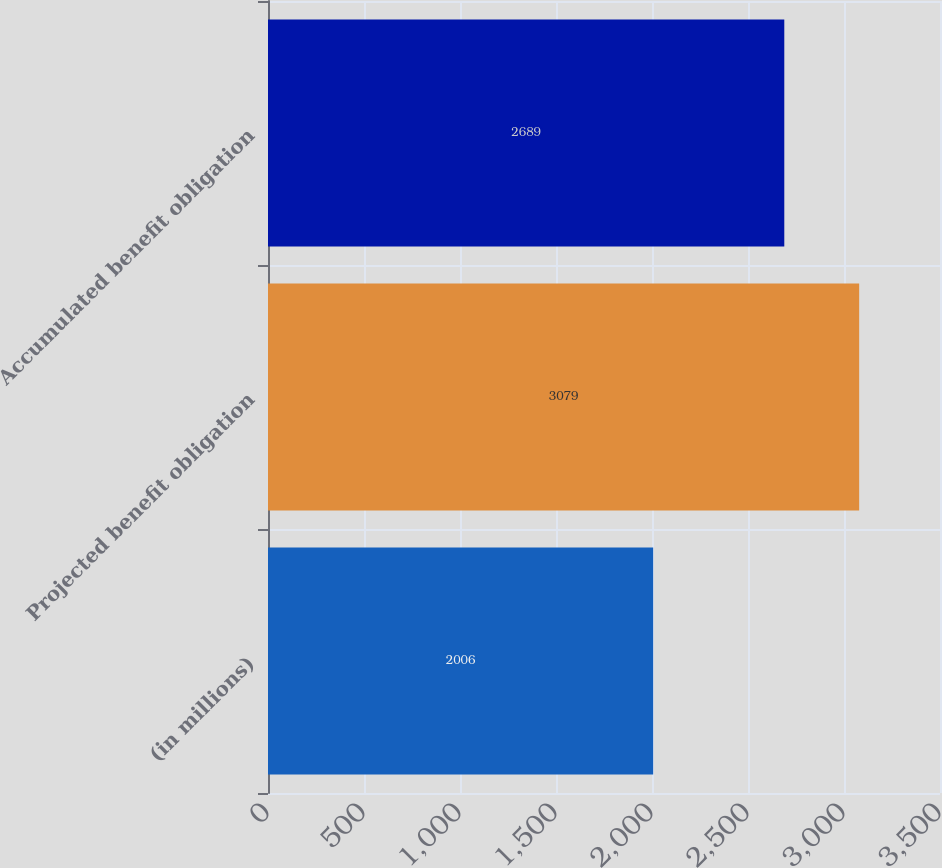Convert chart. <chart><loc_0><loc_0><loc_500><loc_500><bar_chart><fcel>(in millions)<fcel>Projected benefit obligation<fcel>Accumulated benefit obligation<nl><fcel>2006<fcel>3079<fcel>2689<nl></chart> 